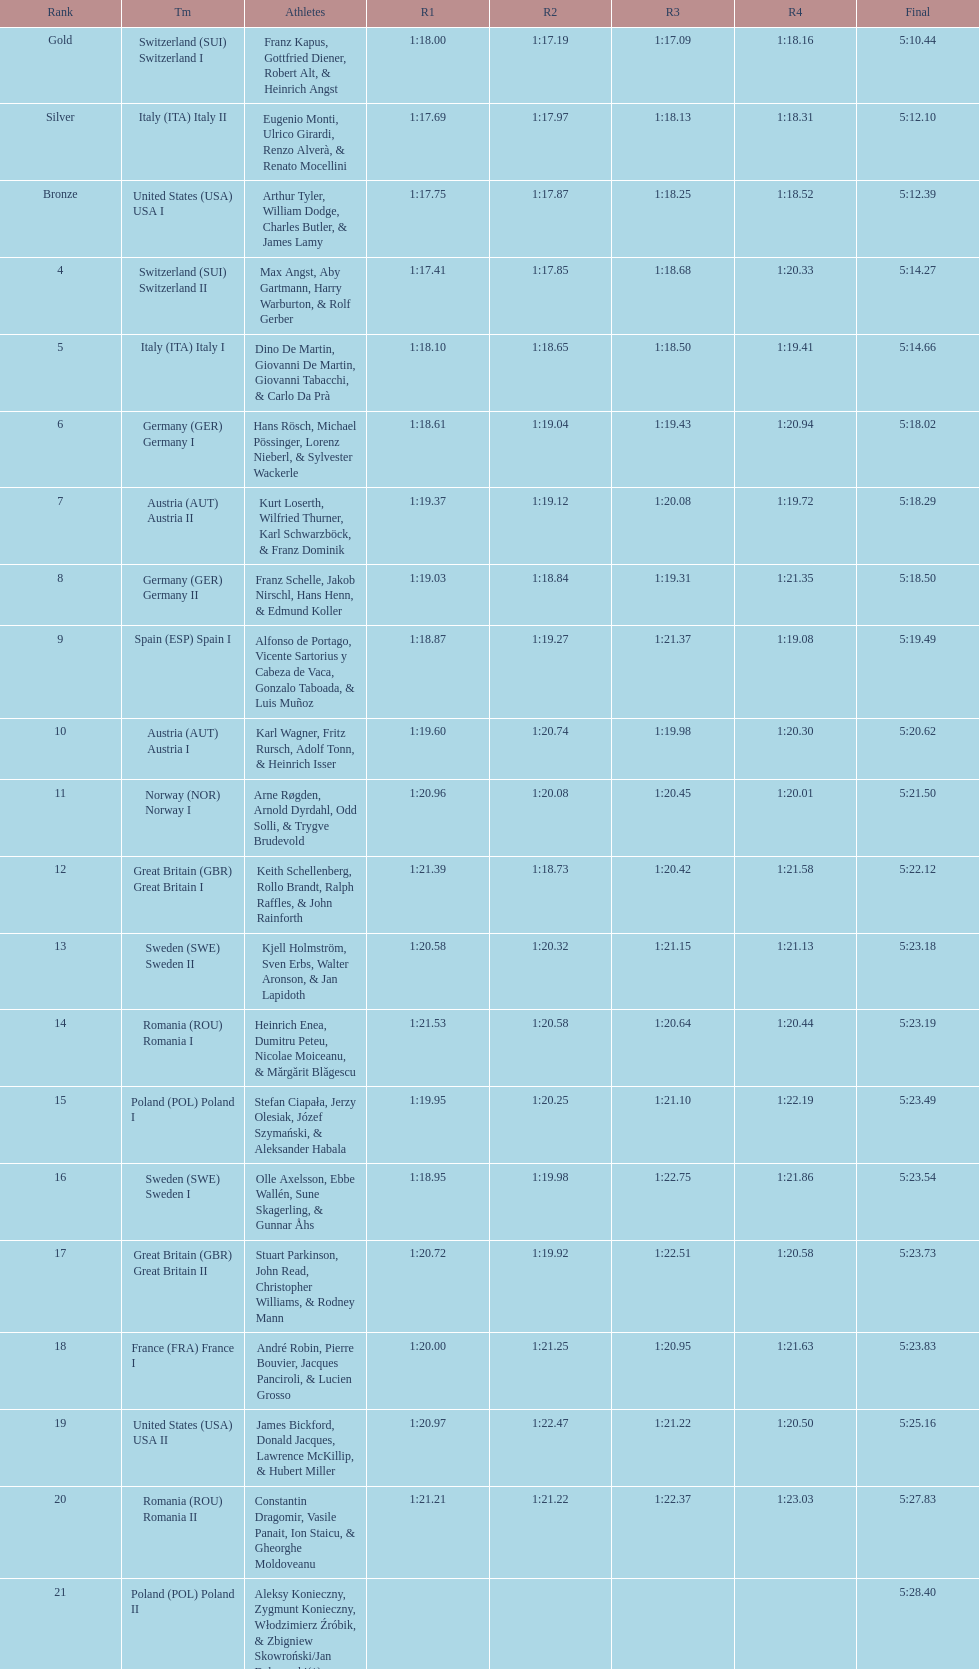Which team had the most time? Poland. I'm looking to parse the entire table for insights. Could you assist me with that? {'header': ['Rank', 'Tm', 'Athletes', 'R1', 'R2', 'R3', 'R4', 'Final'], 'rows': [['Gold', 'Switzerland\xa0(SUI) Switzerland I', 'Franz Kapus, Gottfried Diener, Robert Alt, & Heinrich Angst', '1:18.00', '1:17.19', '1:17.09', '1:18.16', '5:10.44'], ['Silver', 'Italy\xa0(ITA) Italy II', 'Eugenio Monti, Ulrico Girardi, Renzo Alverà, & Renato Mocellini', '1:17.69', '1:17.97', '1:18.13', '1:18.31', '5:12.10'], ['Bronze', 'United States\xa0(USA) USA I', 'Arthur Tyler, William Dodge, Charles Butler, & James Lamy', '1:17.75', '1:17.87', '1:18.25', '1:18.52', '5:12.39'], ['4', 'Switzerland\xa0(SUI) Switzerland II', 'Max Angst, Aby Gartmann, Harry Warburton, & Rolf Gerber', '1:17.41', '1:17.85', '1:18.68', '1:20.33', '5:14.27'], ['5', 'Italy\xa0(ITA) Italy I', 'Dino De Martin, Giovanni De Martin, Giovanni Tabacchi, & Carlo Da Prà', '1:18.10', '1:18.65', '1:18.50', '1:19.41', '5:14.66'], ['6', 'Germany\xa0(GER) Germany I', 'Hans Rösch, Michael Pössinger, Lorenz Nieberl, & Sylvester Wackerle', '1:18.61', '1:19.04', '1:19.43', '1:20.94', '5:18.02'], ['7', 'Austria\xa0(AUT) Austria II', 'Kurt Loserth, Wilfried Thurner, Karl Schwarzböck, & Franz Dominik', '1:19.37', '1:19.12', '1:20.08', '1:19.72', '5:18.29'], ['8', 'Germany\xa0(GER) Germany II', 'Franz Schelle, Jakob Nirschl, Hans Henn, & Edmund Koller', '1:19.03', '1:18.84', '1:19.31', '1:21.35', '5:18.50'], ['9', 'Spain\xa0(ESP) Spain I', 'Alfonso de Portago, Vicente Sartorius y Cabeza de Vaca, Gonzalo Taboada, & Luis Muñoz', '1:18.87', '1:19.27', '1:21.37', '1:19.08', '5:19.49'], ['10', 'Austria\xa0(AUT) Austria I', 'Karl Wagner, Fritz Rursch, Adolf Tonn, & Heinrich Isser', '1:19.60', '1:20.74', '1:19.98', '1:20.30', '5:20.62'], ['11', 'Norway\xa0(NOR) Norway I', 'Arne Røgden, Arnold Dyrdahl, Odd Solli, & Trygve Brudevold', '1:20.96', '1:20.08', '1:20.45', '1:20.01', '5:21.50'], ['12', 'Great Britain\xa0(GBR) Great Britain I', 'Keith Schellenberg, Rollo Brandt, Ralph Raffles, & John Rainforth', '1:21.39', '1:18.73', '1:20.42', '1:21.58', '5:22.12'], ['13', 'Sweden\xa0(SWE) Sweden II', 'Kjell Holmström, Sven Erbs, Walter Aronson, & Jan Lapidoth', '1:20.58', '1:20.32', '1:21.15', '1:21.13', '5:23.18'], ['14', 'Romania\xa0(ROU) Romania I', 'Heinrich Enea, Dumitru Peteu, Nicolae Moiceanu, & Mărgărit Blăgescu', '1:21.53', '1:20.58', '1:20.64', '1:20.44', '5:23.19'], ['15', 'Poland\xa0(POL) Poland I', 'Stefan Ciapała, Jerzy Olesiak, Józef Szymański, & Aleksander Habala', '1:19.95', '1:20.25', '1:21.10', '1:22.19', '5:23.49'], ['16', 'Sweden\xa0(SWE) Sweden I', 'Olle Axelsson, Ebbe Wallén, Sune Skagerling, & Gunnar Åhs', '1:18.95', '1:19.98', '1:22.75', '1:21.86', '5:23.54'], ['17', 'Great Britain\xa0(GBR) Great Britain II', 'Stuart Parkinson, John Read, Christopher Williams, & Rodney Mann', '1:20.72', '1:19.92', '1:22.51', '1:20.58', '5:23.73'], ['18', 'France\xa0(FRA) France I', 'André Robin, Pierre Bouvier, Jacques Panciroli, & Lucien Grosso', '1:20.00', '1:21.25', '1:20.95', '1:21.63', '5:23.83'], ['19', 'United States\xa0(USA) USA II', 'James Bickford, Donald Jacques, Lawrence McKillip, & Hubert Miller', '1:20.97', '1:22.47', '1:21.22', '1:20.50', '5:25.16'], ['20', 'Romania\xa0(ROU) Romania II', 'Constantin Dragomir, Vasile Panait, Ion Staicu, & Gheorghe Moldoveanu', '1:21.21', '1:21.22', '1:22.37', '1:23.03', '5:27.83'], ['21', 'Poland\xa0(POL) Poland II', 'Aleksy Konieczny, Zygmunt Konieczny, Włodzimierz Źróbik, & Zbigniew Skowroński/Jan Dąbrowski(*)', '', '', '', '', '5:28.40']]} 